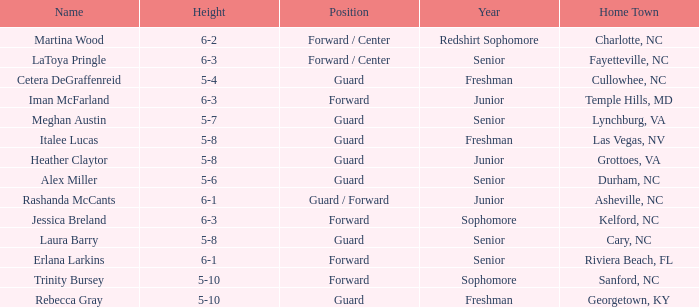How tall is the freshman guard Cetera Degraffenreid? 5-4. 